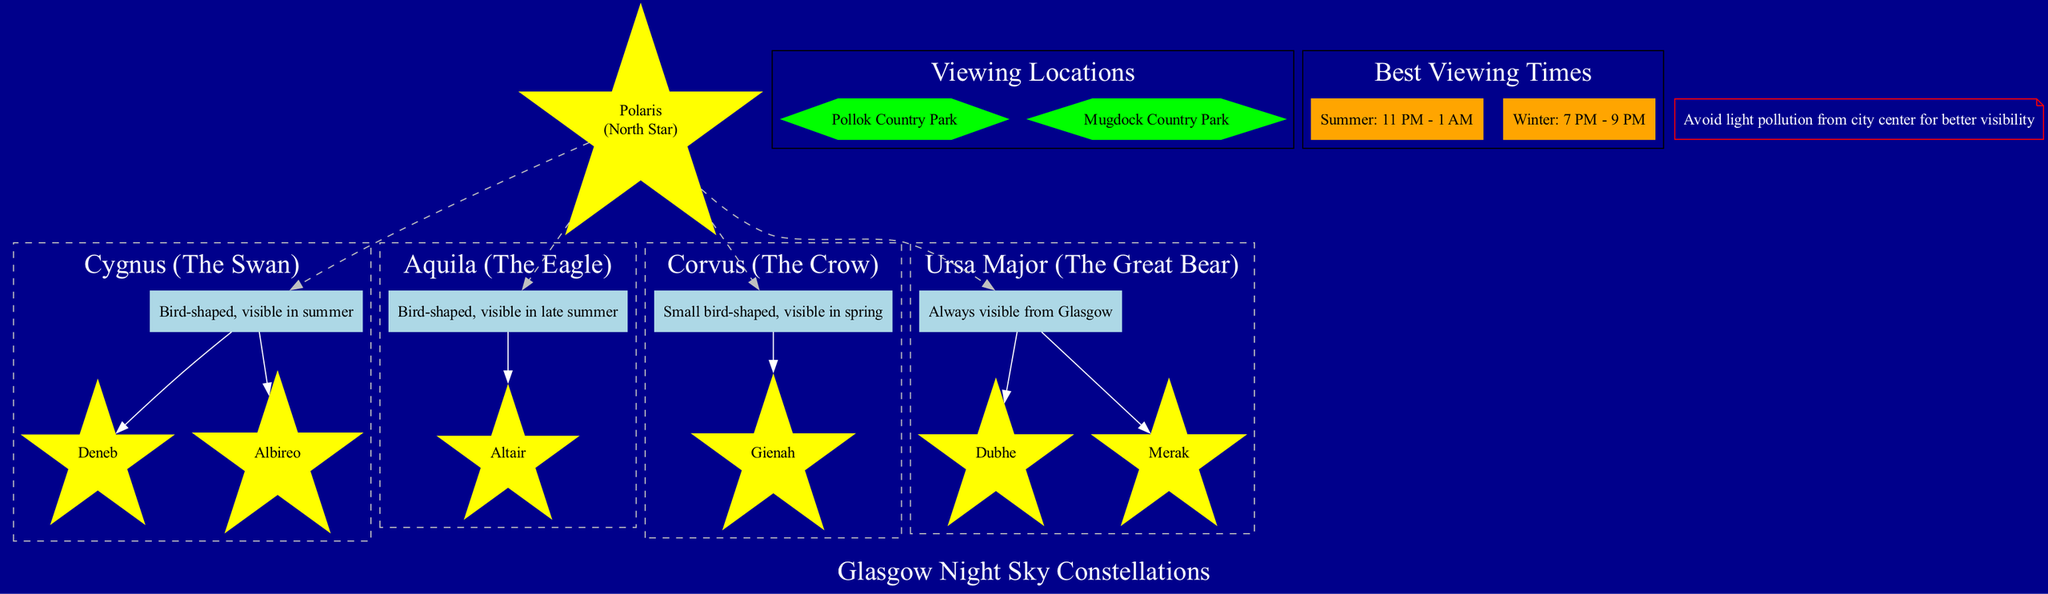what is the center of the diagram? The diagram specifies that the center is labeled as "Polaris (North Star)." This can be directly seen at the center node of the diagram.
Answer: Polaris (North Star) how many constellations are bird-shaped? The diagram lists three constellations identified as bird-shaped: Cygnus (The Swan), Aquila (The Eagle), and Corvus (The Crow). This information is under the constellations section.
Answer: 3 what are the key stars of Cygnus? The diagram explicitly lists the key stars for Cygnus as "Deneb" and "Albireo." This information is detailed within the subgraph for Cygnus.
Answer: Deneb, Albireo which constellation is always visible from Glasgow? The diagram states that Ursa Major (The Great Bear) is always visible from Glasgow. This is specifically labeled as a fact about this constellation.
Answer: Ursa Major (The Great Bear) what is the best viewing time for constellations in summer? The best viewing time for constellations in summer, according to the diagram, is specified as "11 PM - 1 AM." This is indicated in the best viewing times subgraph.
Answer: 11 PM - 1 AM which viewing location is noted in the diagram for observing the night sky? Pollok Country Park is noted as one of the viewing locations in the diagram. This information is captured in the section dedicated to viewing locations.
Answer: Pollok Country Park how many key stars does Aquila have? The diagram shows that Aquila has one key star, which is "Altair." This is mentioned under the description of the Aquila constellation.
Answer: 1 what is a crucial note to consider when viewing constellations from Glasgow? The diagram emphasizes that it’s important to avoid light pollution from the city center to achieve better visibility of the stars. This note is clearly displayed in the diagram.
Answer: Avoid light pollution from city center for better visibility 